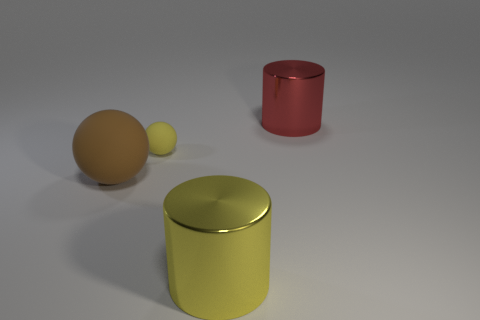What number of green matte things are there?
Make the answer very short. 0. Do the tiny yellow thing and the brown thing that is behind the big yellow metallic cylinder have the same shape?
Ensure brevity in your answer.  Yes. How many things are big brown shiny objects or big things in front of the red object?
Ensure brevity in your answer.  2. There is another thing that is the same shape as the red thing; what is its material?
Your answer should be compact. Metal. There is a large yellow shiny object to the right of the big matte object; does it have the same shape as the big red thing?
Your answer should be very brief. Yes. Is there anything else that has the same size as the yellow matte thing?
Ensure brevity in your answer.  No. Is the number of yellow shiny objects in front of the yellow sphere less than the number of large objects that are to the right of the big brown object?
Provide a succinct answer. Yes. There is a ball on the right side of the big matte sphere behind the cylinder to the left of the red shiny object; what size is it?
Your answer should be very brief. Small. What number of yellow objects are small blocks or tiny things?
Provide a short and direct response. 1. What is the shape of the metal object that is in front of the metal object that is behind the big yellow cylinder?
Ensure brevity in your answer.  Cylinder. 